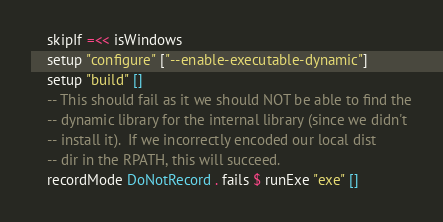Convert code to text. <code><loc_0><loc_0><loc_500><loc_500><_Haskell_>    skipIf =<< isWindows
    setup "configure" ["--enable-executable-dynamic"]
    setup "build" []
    -- This should fail as it we should NOT be able to find the
    -- dynamic library for the internal library (since we didn't
    -- install it).  If we incorrectly encoded our local dist
    -- dir in the RPATH, this will succeed.
    recordMode DoNotRecord . fails $ runExe "exe" []
</code> 